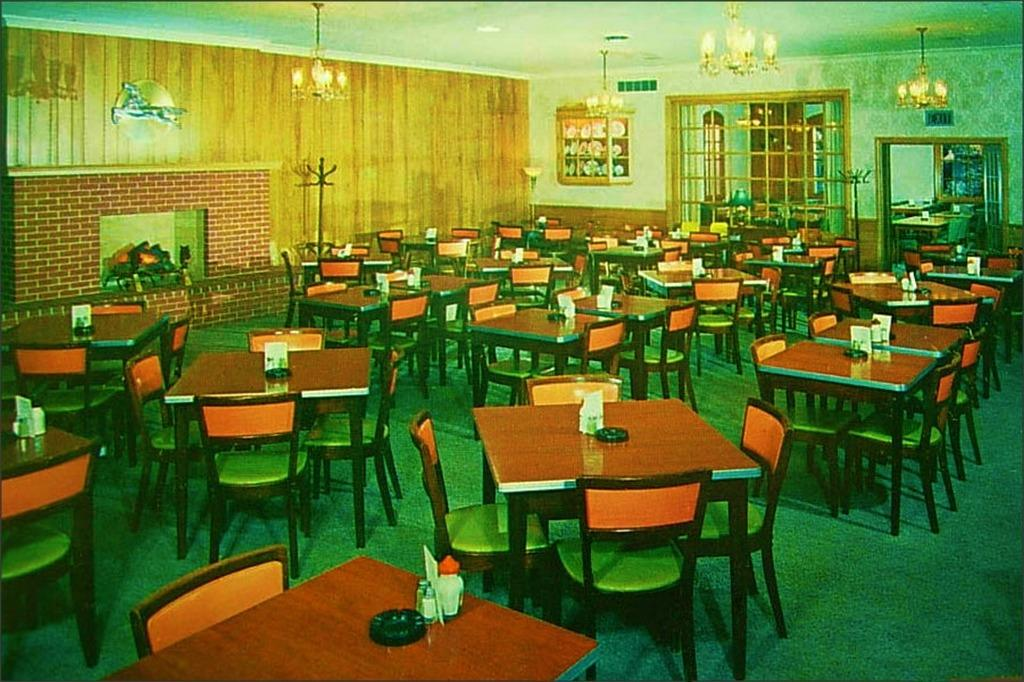What type of establishment is depicted in the image? The image appears to depict a restaurant. How many tables are visible in the image? There are multiple tables in the image. What are the chairs used for in the image? The chairs are associated with the tables in the image, likely for seating customers. What type of haircut does the stranger have in the image? There is no stranger present in the image, so it is not possible to determine their haircut. 